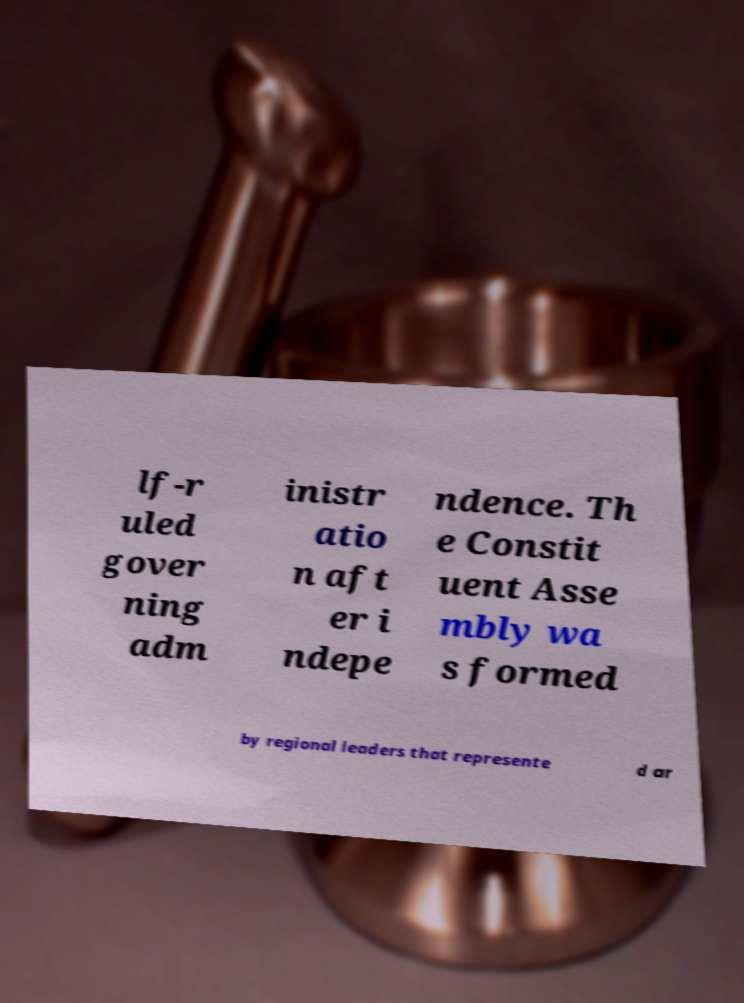Please read and relay the text visible in this image. What does it say? lf-r uled gover ning adm inistr atio n aft er i ndepe ndence. Th e Constit uent Asse mbly wa s formed by regional leaders that represente d ar 